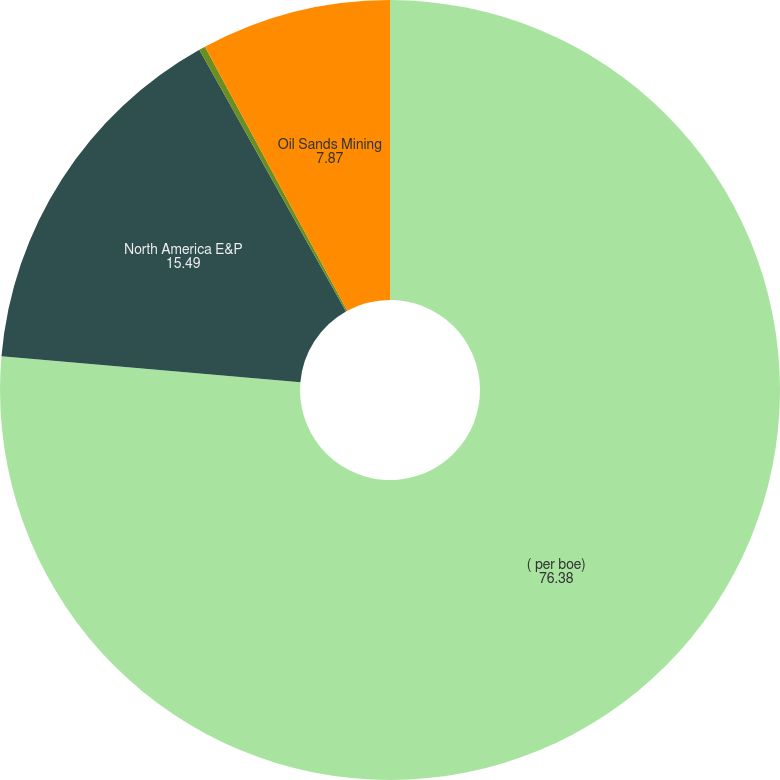<chart> <loc_0><loc_0><loc_500><loc_500><pie_chart><fcel>( per boe)<fcel>North America E&P<fcel>International E&P<fcel>Oil Sands Mining<nl><fcel>76.38%<fcel>15.49%<fcel>0.26%<fcel>7.87%<nl></chart> 